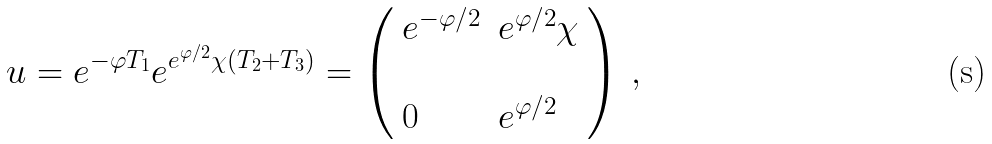Convert formula to latex. <formula><loc_0><loc_0><loc_500><loc_500>u = e ^ { - \varphi T _ { 1 } } e ^ { e ^ { \varphi / 2 } \chi ( T _ { 2 } + T _ { 3 } ) } = \left ( \begin{array} { l l } e ^ { - \varphi / 2 } & e ^ { \varphi / 2 } \chi \\ & \\ 0 & e ^ { \varphi / 2 } \\ \end{array} \right ) \, ,</formula> 